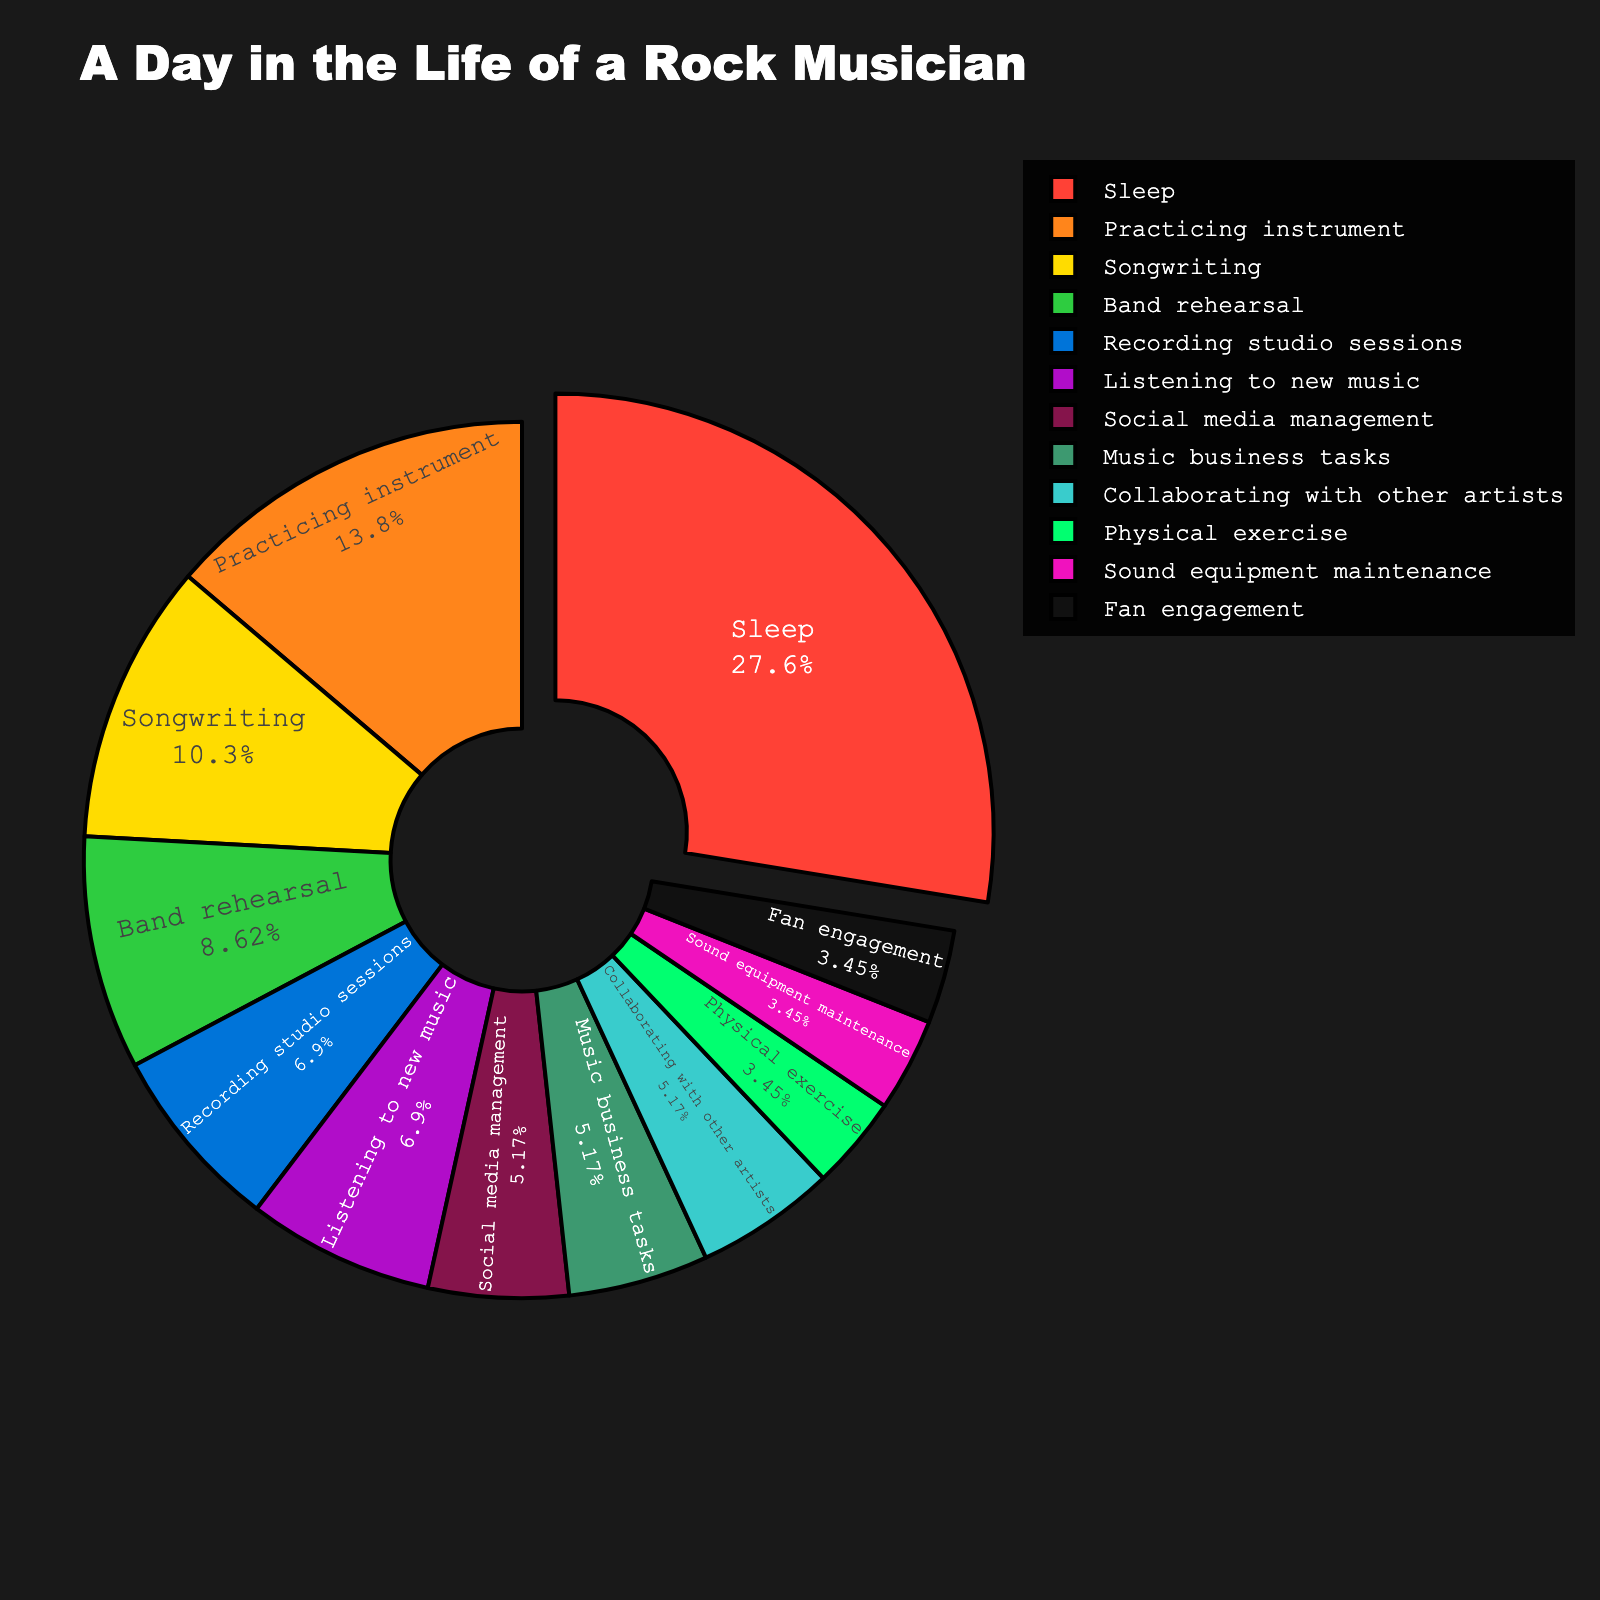Which activity takes the largest portion of a rock musician's daily routine? By looking at the pie chart, the activity that occupies the largest slice is the one with the highest percentage.
Answer: Sleep What is the combined total time spent on songwriting, band rehearsal, and recording studio sessions? Add the hours dedicated to songwriting (3), band rehearsal (2.5), and recording studio sessions (2). The total is 3 + 2.5 + 2 = 7.5 hours.
Answer: 7.5 hours How does the time allocated to practicing the instrument compare to the time spent on fan engagement? Identify the slices corresponding to practicing the instrument and fan engagement. Practicing the instrument takes 4 hours, while fan engagement takes 1 hour. Therefore, practicing the instrument takes more time.
Answer: Practicing instrument takes more time Is more time allocated to social media management or music business tasks? Compare the slices for social media management and music business tasks. Social media management is 1.5 hours, and music business tasks are also 1.5 hours. So, they are equal.
Answer: Equal What percentage of the day is spent on physical exercise? The pie chart shows the percentage for physical exercise. Physical exercise takes 1 hour out of the total 30 hours. So, the percentage is (1/30)*100 = 3.33%.
Answer: 3.33% Which activities occupy a smaller portion of time than collaborating with other artists? Collaborating with other artists takes 1.5 hours. The activities with fewer hours are physical exercise (1), sound equipment maintenance (1), and fan engagement (1).
Answer: Physical exercise, sound equipment maintenance, fan engagement What is the difference in time between listening to new music and sound equipment maintenance? Identify the slices for listening to new music (2 hours) and sound equipment maintenance (1 hour). The difference is 2 - 1 = 1 hour.
Answer: 1 hour What are the total hours spent on activities related to music creation (songwriting, practicing instrument, and band rehearsal)? Sum the hours for songwriting (3), practicing instrument (4), and band rehearsal (2.5). The total is 3 + 4 + 2.5 = 9.5 hours.
Answer: 9.5 hours What activities have the same allocated time as sound equipment maintenance? Sound equipment maintenance is 1 hour. The activities with the same time allocation are physical exercise and fan engagement.
Answer: Physical exercise, fan engagement 